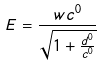<formula> <loc_0><loc_0><loc_500><loc_500>E = \frac { w c ^ { 0 } } { \sqrt { 1 + \frac { d ^ { 0 } } { c ^ { 0 } } } }</formula> 